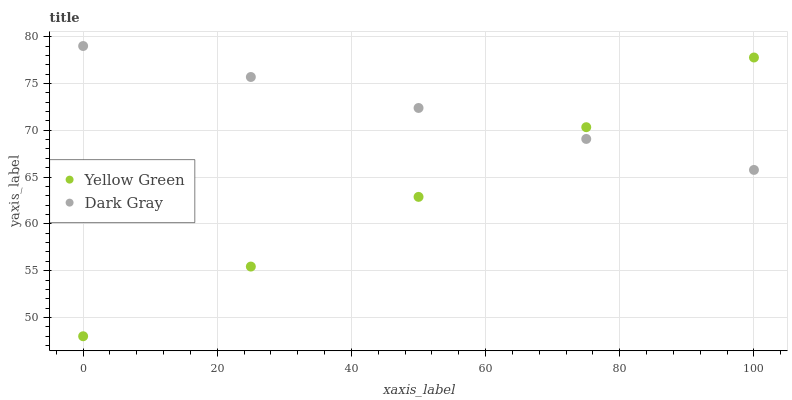Does Yellow Green have the minimum area under the curve?
Answer yes or no. Yes. Does Dark Gray have the maximum area under the curve?
Answer yes or no. Yes. Does Yellow Green have the maximum area under the curve?
Answer yes or no. No. Is Yellow Green the smoothest?
Answer yes or no. Yes. Is Dark Gray the roughest?
Answer yes or no. Yes. Is Yellow Green the roughest?
Answer yes or no. No. Does Yellow Green have the lowest value?
Answer yes or no. Yes. Does Dark Gray have the highest value?
Answer yes or no. Yes. Does Yellow Green have the highest value?
Answer yes or no. No. Does Yellow Green intersect Dark Gray?
Answer yes or no. Yes. Is Yellow Green less than Dark Gray?
Answer yes or no. No. Is Yellow Green greater than Dark Gray?
Answer yes or no. No. 